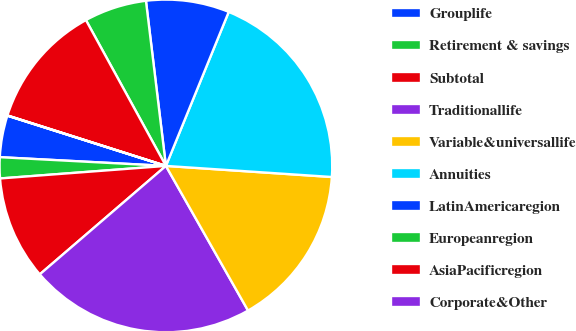Convert chart. <chart><loc_0><loc_0><loc_500><loc_500><pie_chart><fcel>Grouplife<fcel>Retirement & savings<fcel>Subtotal<fcel>Traditionallife<fcel>Variable&universallife<fcel>Annuities<fcel>LatinAmericaregion<fcel>Europeanregion<fcel>AsiaPacificregion<fcel>Corporate&Other<nl><fcel>4.05%<fcel>2.04%<fcel>10.1%<fcel>21.92%<fcel>15.72%<fcel>19.9%<fcel>8.08%<fcel>6.07%<fcel>12.11%<fcel>0.02%<nl></chart> 